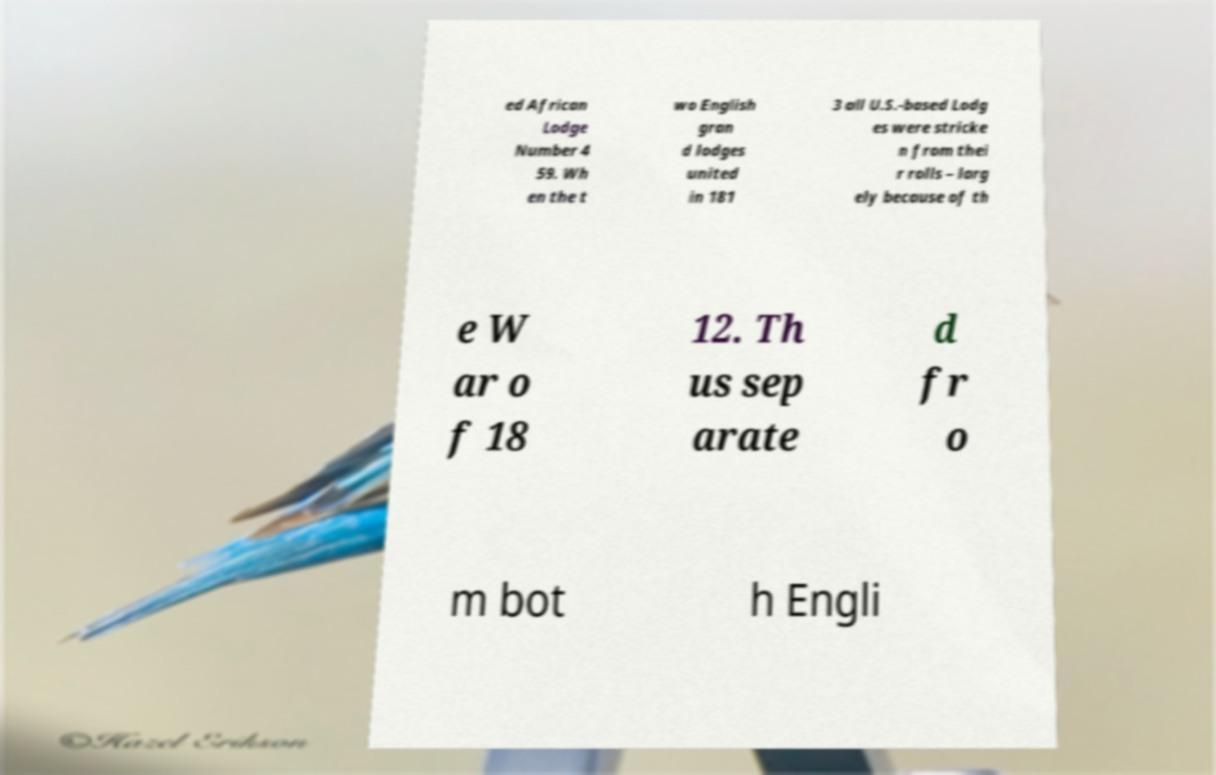Can you read and provide the text displayed in the image?This photo seems to have some interesting text. Can you extract and type it out for me? ed African Lodge Number 4 59. Wh en the t wo English gran d lodges united in 181 3 all U.S.-based Lodg es were stricke n from thei r rolls – larg ely because of th e W ar o f 18 12. Th us sep arate d fr o m bot h Engli 